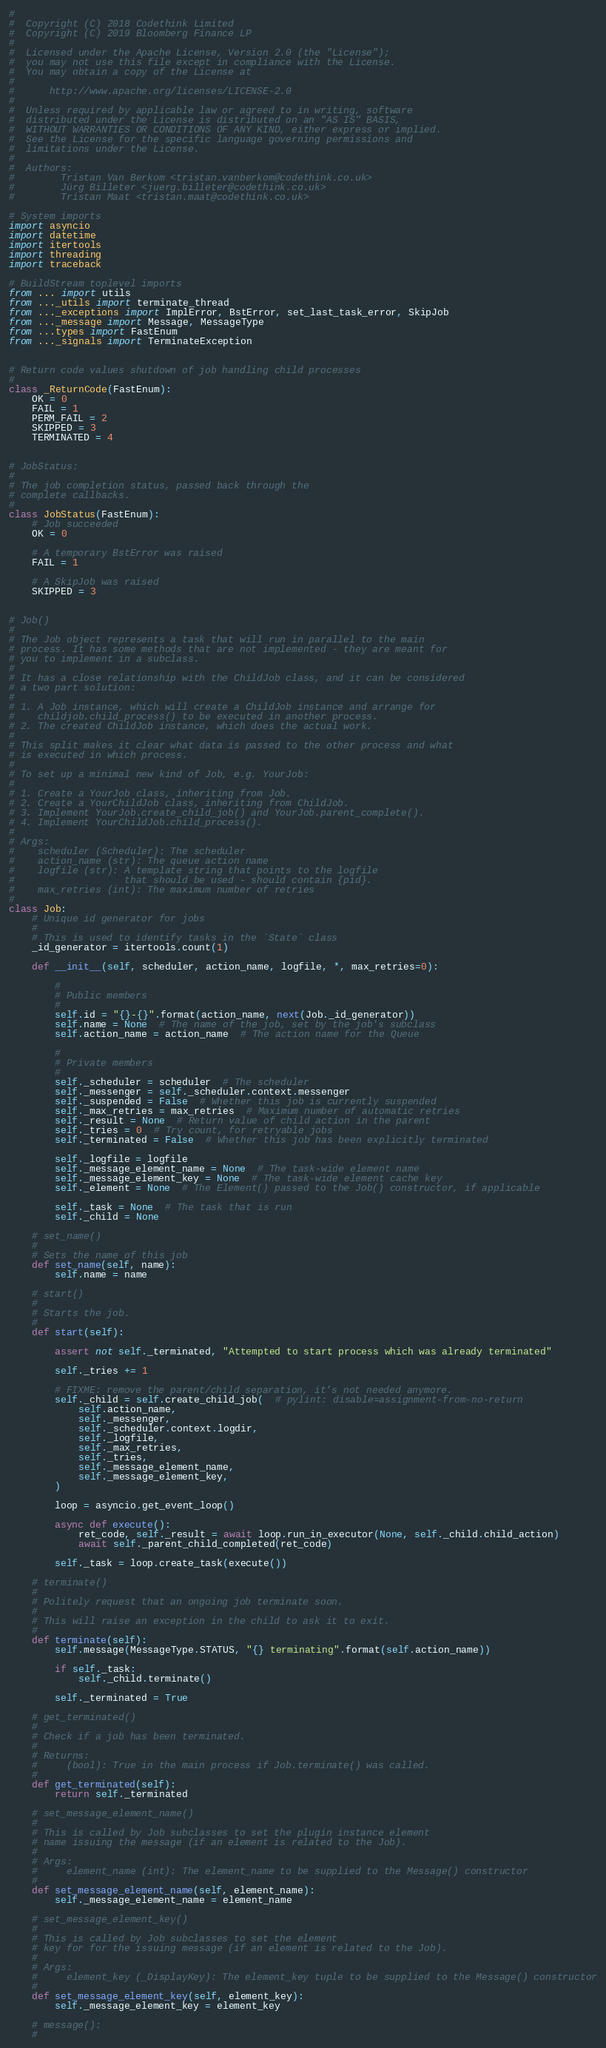Convert code to text. <code><loc_0><loc_0><loc_500><loc_500><_Python_>#
#  Copyright (C) 2018 Codethink Limited
#  Copyright (C) 2019 Bloomberg Finance LP
#
#  Licensed under the Apache License, Version 2.0 (the "License");
#  you may not use this file except in compliance with the License.
#  You may obtain a copy of the License at
#
#      http://www.apache.org/licenses/LICENSE-2.0
#
#  Unless required by applicable law or agreed to in writing, software
#  distributed under the License is distributed on an "AS IS" BASIS,
#  WITHOUT WARRANTIES OR CONDITIONS OF ANY KIND, either express or implied.
#  See the License for the specific language governing permissions and
#  limitations under the License.
#
#  Authors:
#        Tristan Van Berkom <tristan.vanberkom@codethink.co.uk>
#        Jürg Billeter <juerg.billeter@codethink.co.uk>
#        Tristan Maat <tristan.maat@codethink.co.uk>

# System imports
import asyncio
import datetime
import itertools
import threading
import traceback

# BuildStream toplevel imports
from ... import utils
from ..._utils import terminate_thread
from ..._exceptions import ImplError, BstError, set_last_task_error, SkipJob
from ..._message import Message, MessageType
from ...types import FastEnum
from ..._signals import TerminateException


# Return code values shutdown of job handling child processes
#
class _ReturnCode(FastEnum):
    OK = 0
    FAIL = 1
    PERM_FAIL = 2
    SKIPPED = 3
    TERMINATED = 4


# JobStatus:
#
# The job completion status, passed back through the
# complete callbacks.
#
class JobStatus(FastEnum):
    # Job succeeded
    OK = 0

    # A temporary BstError was raised
    FAIL = 1

    # A SkipJob was raised
    SKIPPED = 3


# Job()
#
# The Job object represents a task that will run in parallel to the main
# process. It has some methods that are not implemented - they are meant for
# you to implement in a subclass.
#
# It has a close relationship with the ChildJob class, and it can be considered
# a two part solution:
#
# 1. A Job instance, which will create a ChildJob instance and arrange for
#    childjob.child_process() to be executed in another process.
# 2. The created ChildJob instance, which does the actual work.
#
# This split makes it clear what data is passed to the other process and what
# is executed in which process.
#
# To set up a minimal new kind of Job, e.g. YourJob:
#
# 1. Create a YourJob class, inheriting from Job.
# 2. Create a YourChildJob class, inheriting from ChildJob.
# 3. Implement YourJob.create_child_job() and YourJob.parent_complete().
# 4. Implement YourChildJob.child_process().
#
# Args:
#    scheduler (Scheduler): The scheduler
#    action_name (str): The queue action name
#    logfile (str): A template string that points to the logfile
#                   that should be used - should contain {pid}.
#    max_retries (int): The maximum number of retries
#
class Job:
    # Unique id generator for jobs
    #
    # This is used to identify tasks in the `State` class
    _id_generator = itertools.count(1)

    def __init__(self, scheduler, action_name, logfile, *, max_retries=0):

        #
        # Public members
        #
        self.id = "{}-{}".format(action_name, next(Job._id_generator))
        self.name = None  # The name of the job, set by the job's subclass
        self.action_name = action_name  # The action name for the Queue

        #
        # Private members
        #
        self._scheduler = scheduler  # The scheduler
        self._messenger = self._scheduler.context.messenger
        self._suspended = False  # Whether this job is currently suspended
        self._max_retries = max_retries  # Maximum number of automatic retries
        self._result = None  # Return value of child action in the parent
        self._tries = 0  # Try count, for retryable jobs
        self._terminated = False  # Whether this job has been explicitly terminated

        self._logfile = logfile
        self._message_element_name = None  # The task-wide element name
        self._message_element_key = None  # The task-wide element cache key
        self._element = None  # The Element() passed to the Job() constructor, if applicable

        self._task = None  # The task that is run
        self._child = None

    # set_name()
    #
    # Sets the name of this job
    def set_name(self, name):
        self.name = name

    # start()
    #
    # Starts the job.
    #
    def start(self):

        assert not self._terminated, "Attempted to start process which was already terminated"

        self._tries += 1

        # FIXME: remove the parent/child separation, it's not needed anymore.
        self._child = self.create_child_job(  # pylint: disable=assignment-from-no-return
            self.action_name,
            self._messenger,
            self._scheduler.context.logdir,
            self._logfile,
            self._max_retries,
            self._tries,
            self._message_element_name,
            self._message_element_key,
        )

        loop = asyncio.get_event_loop()

        async def execute():
            ret_code, self._result = await loop.run_in_executor(None, self._child.child_action)
            await self._parent_child_completed(ret_code)

        self._task = loop.create_task(execute())

    # terminate()
    #
    # Politely request that an ongoing job terminate soon.
    #
    # This will raise an exception in the child to ask it to exit.
    #
    def terminate(self):
        self.message(MessageType.STATUS, "{} terminating".format(self.action_name))

        if self._task:
            self._child.terminate()

        self._terminated = True

    # get_terminated()
    #
    # Check if a job has been terminated.
    #
    # Returns:
    #     (bool): True in the main process if Job.terminate() was called.
    #
    def get_terminated(self):
        return self._terminated

    # set_message_element_name()
    #
    # This is called by Job subclasses to set the plugin instance element
    # name issuing the message (if an element is related to the Job).
    #
    # Args:
    #     element_name (int): The element_name to be supplied to the Message() constructor
    #
    def set_message_element_name(self, element_name):
        self._message_element_name = element_name

    # set_message_element_key()
    #
    # This is called by Job subclasses to set the element
    # key for for the issuing message (if an element is related to the Job).
    #
    # Args:
    #     element_key (_DisplayKey): The element_key tuple to be supplied to the Message() constructor
    #
    def set_message_element_key(self, element_key):
        self._message_element_key = element_key

    # message():
    #</code> 